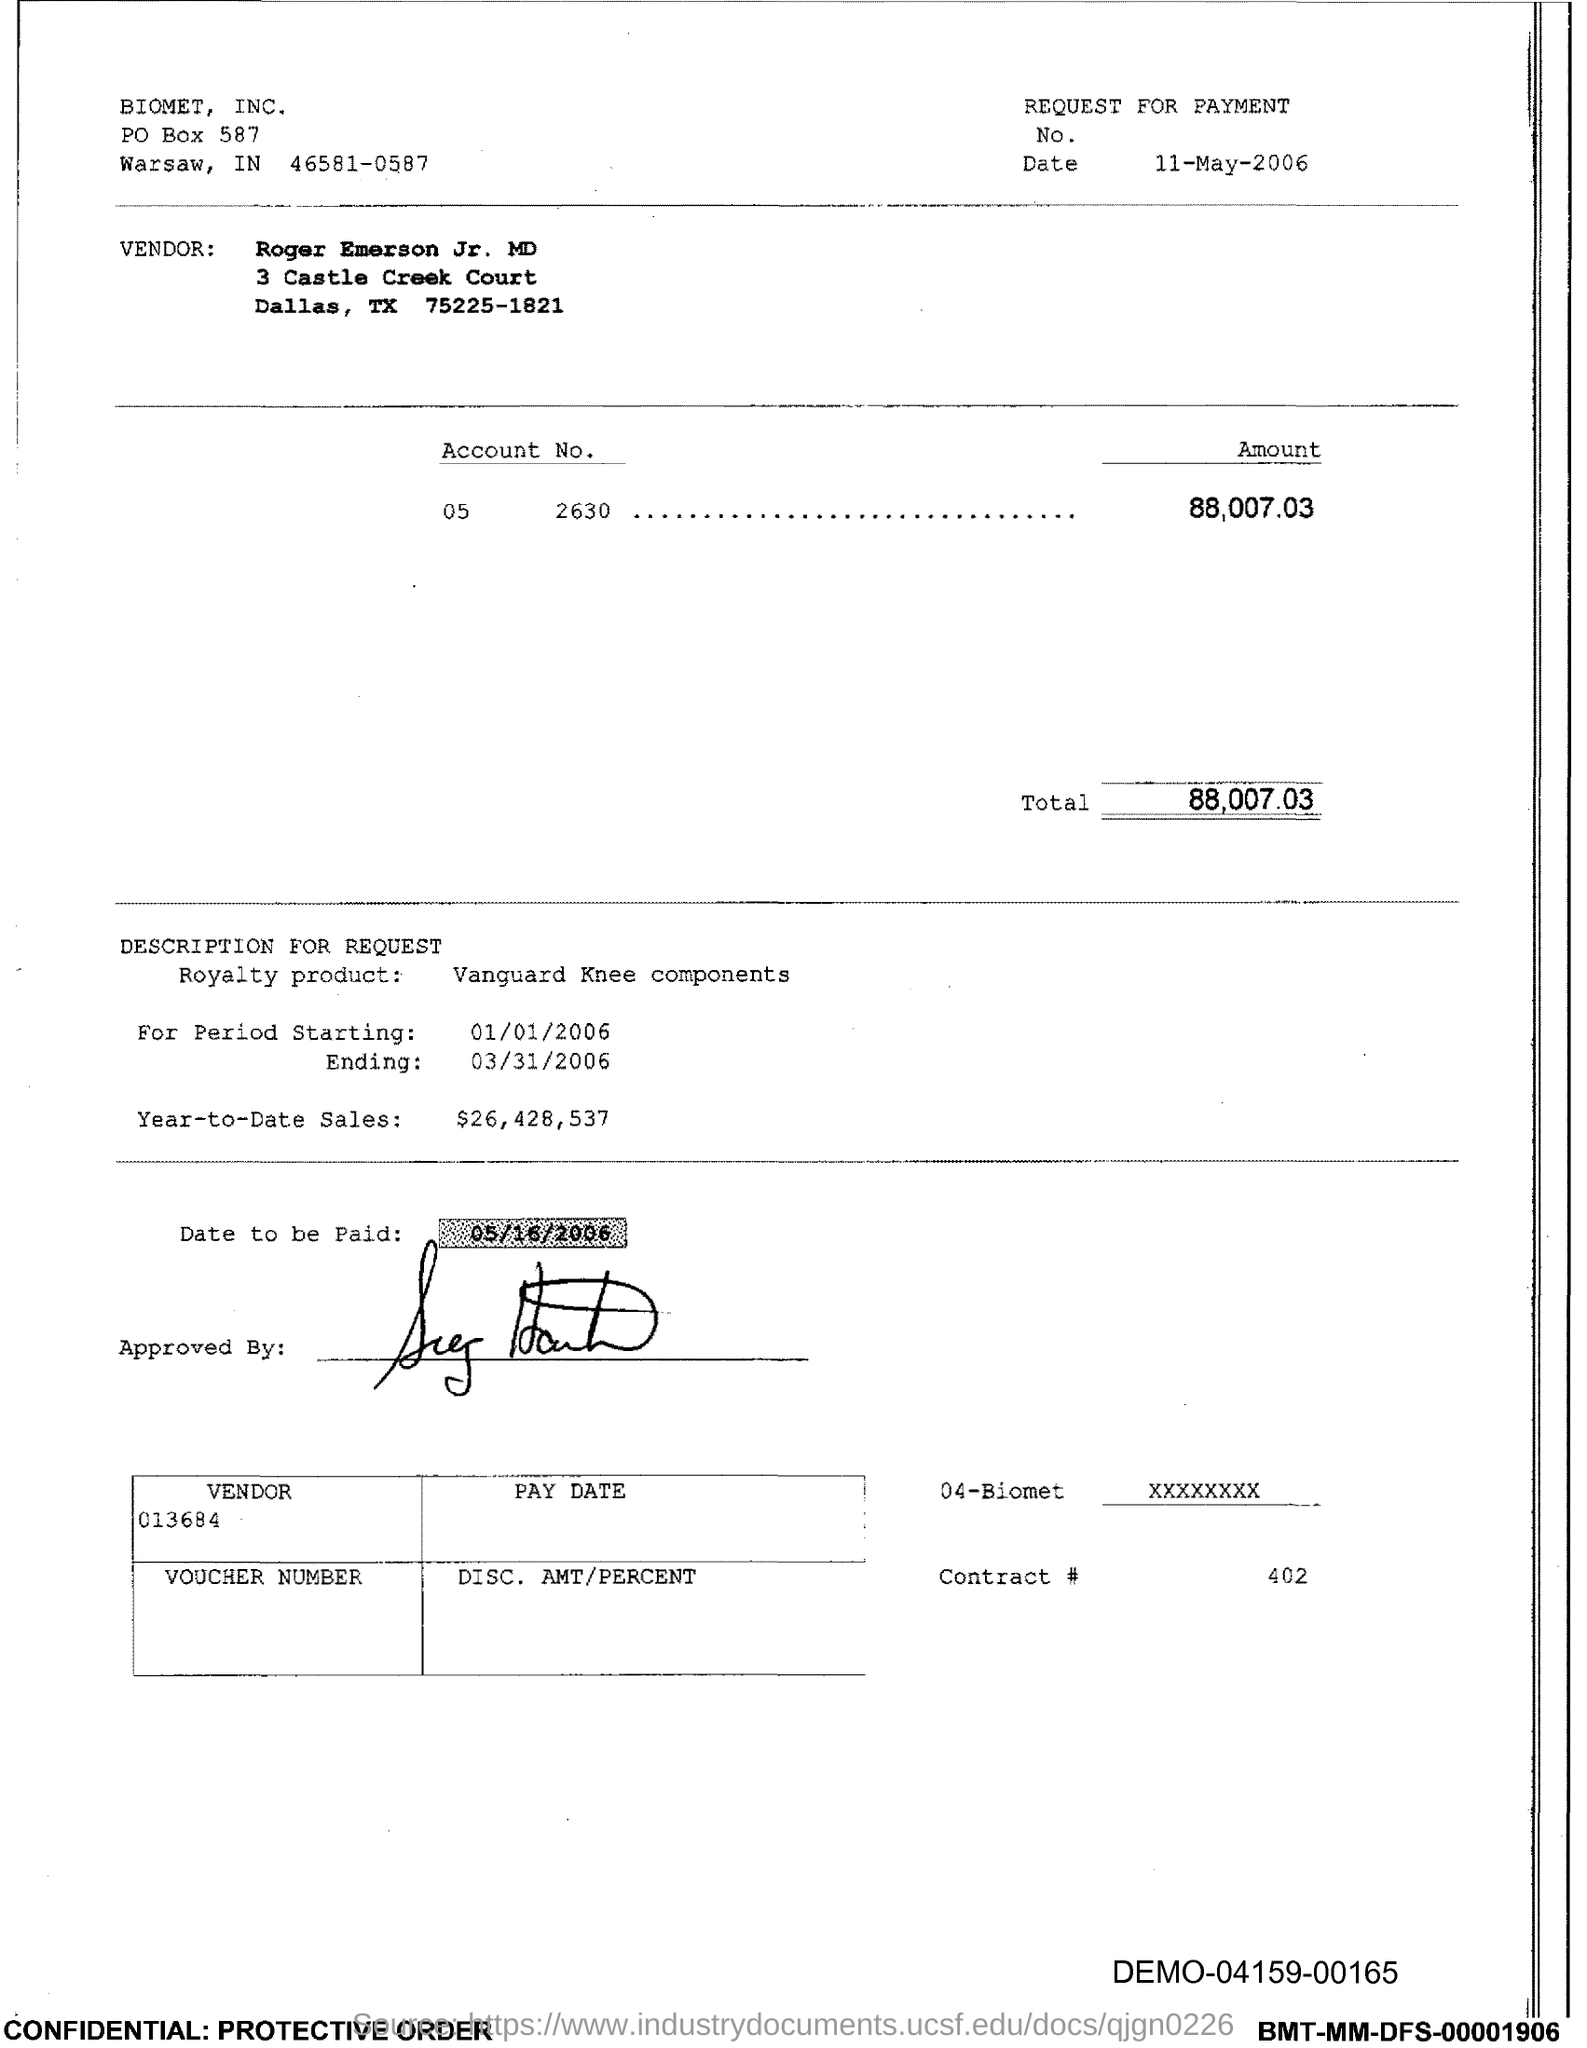Mention a couple of crucial points in this snapshot. The total is 88,007.03. The date is 11 May 2006. The starting period is from 01/01/2006. Year-to-date sales have reached $26,428,537. The amount is 88,007.03. 